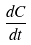<formula> <loc_0><loc_0><loc_500><loc_500>\frac { d C } { d t }</formula> 